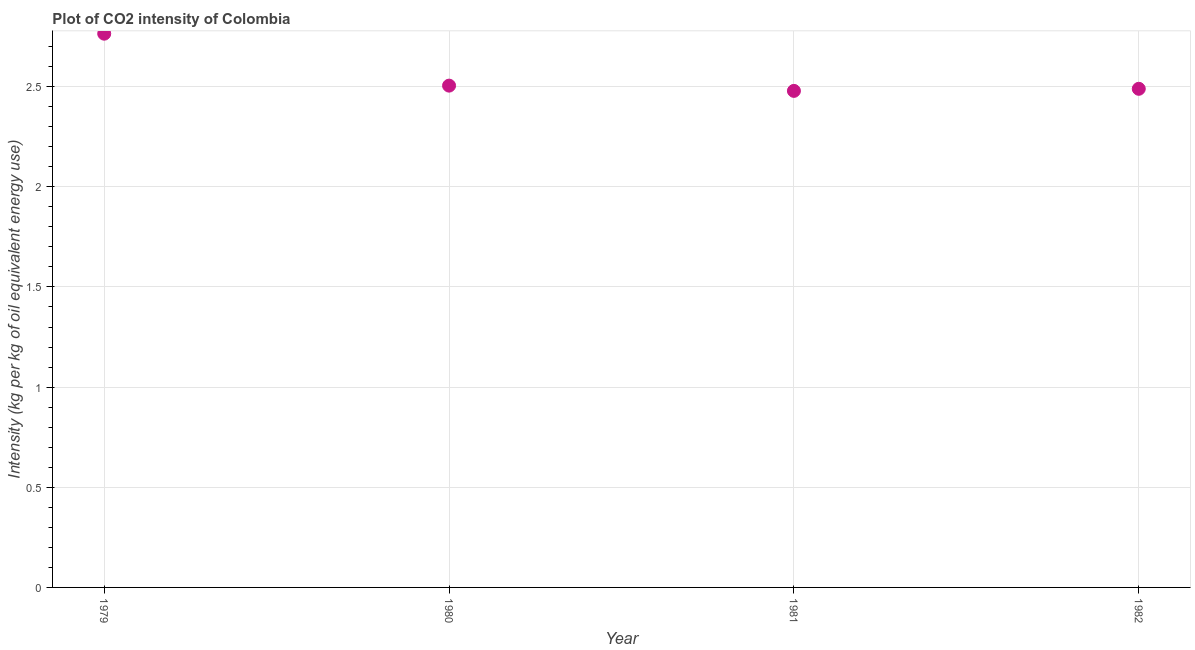What is the co2 intensity in 1979?
Ensure brevity in your answer.  2.76. Across all years, what is the maximum co2 intensity?
Give a very brief answer. 2.76. Across all years, what is the minimum co2 intensity?
Your answer should be very brief. 2.48. In which year was the co2 intensity maximum?
Offer a terse response. 1979. In which year was the co2 intensity minimum?
Keep it short and to the point. 1981. What is the sum of the co2 intensity?
Your answer should be compact. 10.24. What is the difference between the co2 intensity in 1981 and 1982?
Your response must be concise. -0.01. What is the average co2 intensity per year?
Provide a short and direct response. 2.56. What is the median co2 intensity?
Give a very brief answer. 2.5. In how many years, is the co2 intensity greater than 1.1 kg?
Make the answer very short. 4. Do a majority of the years between 1980 and 1981 (inclusive) have co2 intensity greater than 1.9 kg?
Keep it short and to the point. Yes. What is the ratio of the co2 intensity in 1981 to that in 1982?
Provide a short and direct response. 1. Is the co2 intensity in 1980 less than that in 1982?
Provide a short and direct response. No. Is the difference between the co2 intensity in 1979 and 1980 greater than the difference between any two years?
Keep it short and to the point. No. What is the difference between the highest and the second highest co2 intensity?
Keep it short and to the point. 0.26. What is the difference between the highest and the lowest co2 intensity?
Your response must be concise. 0.29. Does the co2 intensity monotonically increase over the years?
Make the answer very short. No. What is the difference between two consecutive major ticks on the Y-axis?
Provide a short and direct response. 0.5. What is the title of the graph?
Offer a terse response. Plot of CO2 intensity of Colombia. What is the label or title of the X-axis?
Give a very brief answer. Year. What is the label or title of the Y-axis?
Keep it short and to the point. Intensity (kg per kg of oil equivalent energy use). What is the Intensity (kg per kg of oil equivalent energy use) in 1979?
Provide a succinct answer. 2.76. What is the Intensity (kg per kg of oil equivalent energy use) in 1980?
Provide a succinct answer. 2.51. What is the Intensity (kg per kg of oil equivalent energy use) in 1981?
Keep it short and to the point. 2.48. What is the Intensity (kg per kg of oil equivalent energy use) in 1982?
Your answer should be very brief. 2.49. What is the difference between the Intensity (kg per kg of oil equivalent energy use) in 1979 and 1980?
Offer a very short reply. 0.26. What is the difference between the Intensity (kg per kg of oil equivalent energy use) in 1979 and 1981?
Your answer should be very brief. 0.29. What is the difference between the Intensity (kg per kg of oil equivalent energy use) in 1979 and 1982?
Your response must be concise. 0.28. What is the difference between the Intensity (kg per kg of oil equivalent energy use) in 1980 and 1981?
Your answer should be compact. 0.03. What is the difference between the Intensity (kg per kg of oil equivalent energy use) in 1980 and 1982?
Offer a terse response. 0.02. What is the difference between the Intensity (kg per kg of oil equivalent energy use) in 1981 and 1982?
Offer a very short reply. -0.01. What is the ratio of the Intensity (kg per kg of oil equivalent energy use) in 1979 to that in 1980?
Give a very brief answer. 1.1. What is the ratio of the Intensity (kg per kg of oil equivalent energy use) in 1979 to that in 1981?
Your response must be concise. 1.11. What is the ratio of the Intensity (kg per kg of oil equivalent energy use) in 1979 to that in 1982?
Provide a short and direct response. 1.11. What is the ratio of the Intensity (kg per kg of oil equivalent energy use) in 1980 to that in 1982?
Offer a very short reply. 1.01. What is the ratio of the Intensity (kg per kg of oil equivalent energy use) in 1981 to that in 1982?
Offer a terse response. 1. 